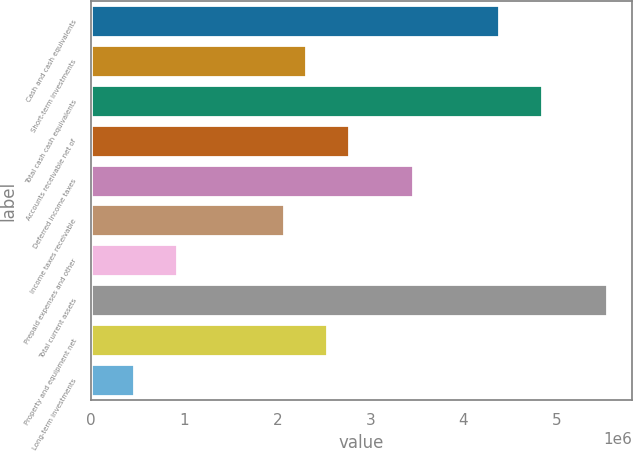Convert chart. <chart><loc_0><loc_0><loc_500><loc_500><bar_chart><fcel>Cash and cash equivalents<fcel>Short-term investments<fcel>Total cash cash equivalents<fcel>Accounts receivable net of<fcel>Deferred income taxes<fcel>Income taxes receivable<fcel>Prepaid expenses and other<fcel>Total current assets<fcel>Property and equipment net<fcel>Long-term investments<nl><fcel>4.38257e+06<fcel>2.30735e+06<fcel>4.84373e+06<fcel>2.76851e+06<fcel>3.46025e+06<fcel>2.07677e+06<fcel>923877<fcel>5.53546e+06<fcel>2.53793e+06<fcel>462719<nl></chart> 